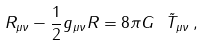<formula> <loc_0><loc_0><loc_500><loc_500>R _ { \mu \nu } - \frac { 1 } { 2 } g _ { \mu \nu } R = 8 \pi G \ \tilde { T } _ { \mu \nu } \, ,</formula> 